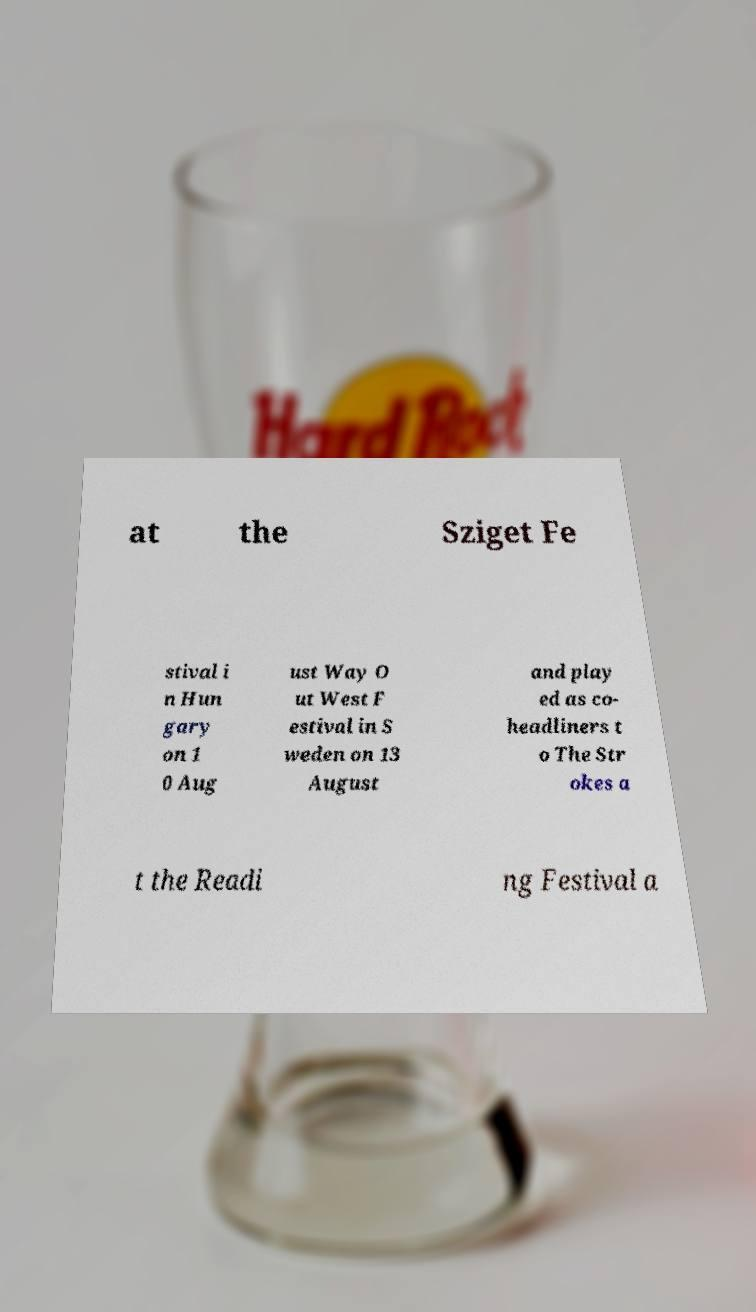I need the written content from this picture converted into text. Can you do that? at the Sziget Fe stival i n Hun gary on 1 0 Aug ust Way O ut West F estival in S weden on 13 August and play ed as co- headliners t o The Str okes a t the Readi ng Festival a 